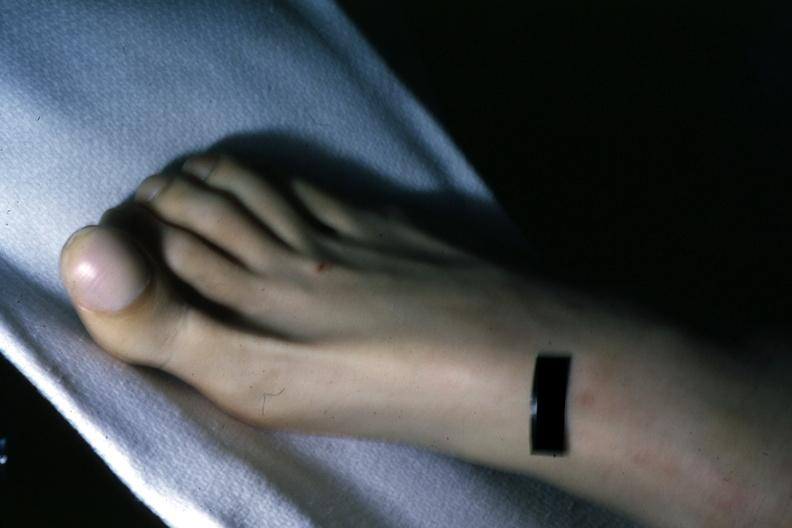what shows clubbing?
Answer the question using a single word or phrase. This great toe 